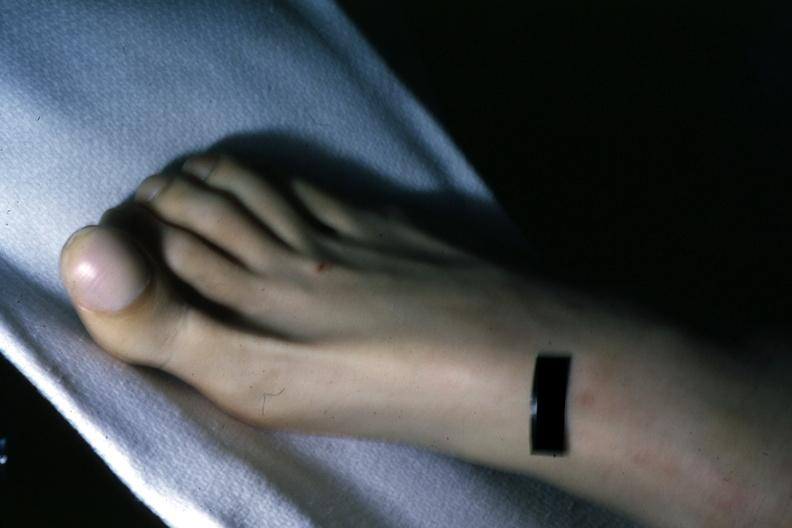what shows clubbing?
Answer the question using a single word or phrase. This great toe 